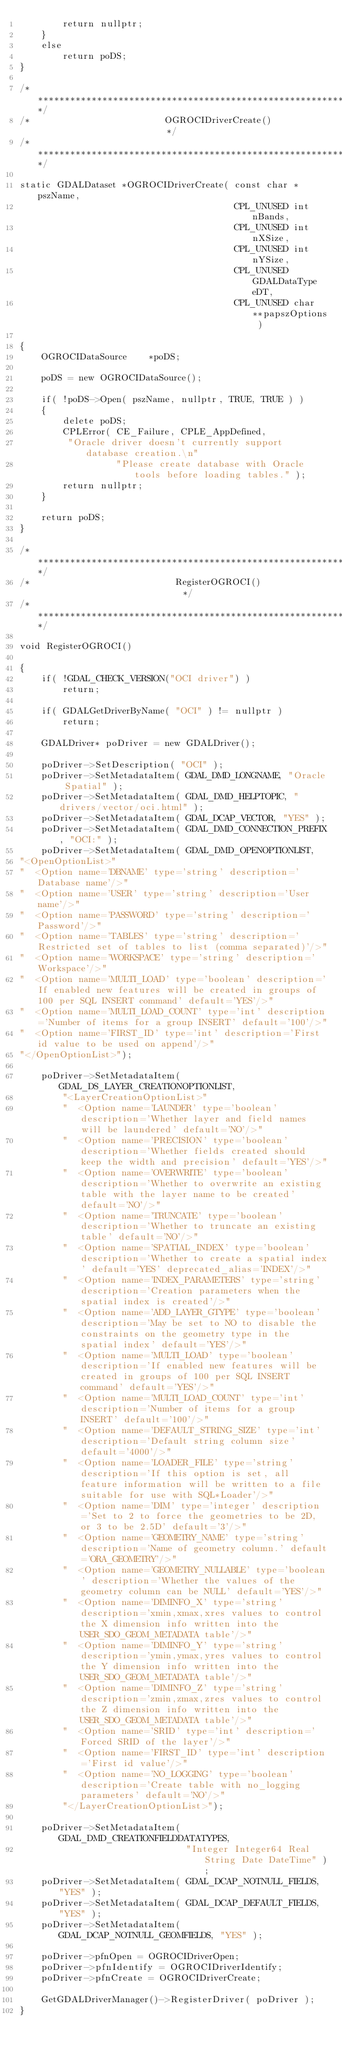<code> <loc_0><loc_0><loc_500><loc_500><_C++_>        return nullptr;
    }
    else
        return poDS;
}

/************************************************************************/
/*                         OGROCIDriverCreate()                         */
/************************************************************************/

static GDALDataset *OGROCIDriverCreate( const char * pszName,
                                        CPL_UNUSED int nBands,
                                        CPL_UNUSED int nXSize,
                                        CPL_UNUSED int nYSize,
                                        CPL_UNUSED GDALDataType eDT,
                                        CPL_UNUSED char **papszOptions )

{
    OGROCIDataSource    *poDS;

    poDS = new OGROCIDataSource();

    if( !poDS->Open( pszName, nullptr, TRUE, TRUE ) )
    {
        delete poDS;
        CPLError( CE_Failure, CPLE_AppDefined,
         "Oracle driver doesn't currently support database creation.\n"
                  "Please create database with Oracle tools before loading tables." );
        return nullptr;
    }

    return poDS;
}

/************************************************************************/
/*                           RegisterOGROCI()                            */
/************************************************************************/

void RegisterOGROCI()

{
    if( !GDAL_CHECK_VERSION("OCI driver") )
        return;

    if( GDALGetDriverByName( "OCI" ) != nullptr )
        return;

    GDALDriver* poDriver = new GDALDriver();

    poDriver->SetDescription( "OCI" );
    poDriver->SetMetadataItem( GDAL_DMD_LONGNAME, "Oracle Spatial" );
    poDriver->SetMetadataItem( GDAL_DMD_HELPTOPIC, "drivers/vector/oci.html" );
    poDriver->SetMetadataItem( GDAL_DCAP_VECTOR, "YES" );
    poDriver->SetMetadataItem( GDAL_DMD_CONNECTION_PREFIX, "OCI:" );
    poDriver->SetMetadataItem( GDAL_DMD_OPENOPTIONLIST,
"<OpenOptionList>"
"  <Option name='DBNAME' type='string' description='Database name'/>"
"  <Option name='USER' type='string' description='User name'/>"
"  <Option name='PASSWORD' type='string' description='Password'/>"
"  <Option name='TABLES' type='string' description='Restricted set of tables to list (comma separated)'/>"
"  <Option name='WORKSPACE' type='string' description='Workspace'/>"
"  <Option name='MULTI_LOAD' type='boolean' description='If enabled new features will be created in groups of 100 per SQL INSERT command' default='YES'/>"
"  <Option name='MULTI_LOAD_COUNT' type='int' description='Number of items for a group INSERT' default='100'/>"
"  <Option name='FIRST_ID' type='int' description='First id value to be used on append'/>"
"</OpenOptionList>");

    poDriver->SetMetadataItem( GDAL_DS_LAYER_CREATIONOPTIONLIST,
        "<LayerCreationOptionList>"
        "  <Option name='LAUNDER' type='boolean' description='Whether layer and field names will be laundered' default='NO'/>"
        "  <Option name='PRECISION' type='boolean' description='Whether fields created should keep the width and precision' default='YES'/>"
        "  <Option name='OVERWRITE' type='boolean' description='Whether to overwrite an existing table with the layer name to be created' default='NO'/>"
        "  <Option name='TRUNCATE' type='boolean' description='Whether to truncate an existing table' default='NO'/>"
        "  <Option name='SPATIAL_INDEX' type='boolean' description='Whether to create a spatial index' default='YES' deprecated_alias='INDEX'/>"
        "  <Option name='INDEX_PARAMETERS' type='string' description='Creation parameters when the spatial index is created'/>"
        "  <Option name='ADD_LAYER_GTYPE' type='boolean' description='May be set to NO to disable the constraints on the geometry type in the spatial index' default='YES'/>"
        "  <Option name='MULTI_LOAD' type='boolean' description='If enabled new features will be created in groups of 100 per SQL INSERT command' default='YES'/>"
        "  <Option name='MULTI_LOAD_COUNT' type='int' description='Number of items for a group INSERT' default='100'/>"
        "  <Option name='DEFAULT_STRING_SIZE' type='int' description='Default string column size' default='4000'/>"
        "  <Option name='LOADER_FILE' type='string' description='If this option is set, all feature information will be written to a file suitable for use with SQL*Loader'/>"
        "  <Option name='DIM' type='integer' description='Set to 2 to force the geometries to be 2D, or 3 to be 2.5D' default='3'/>"
        "  <Option name='GEOMETRY_NAME' type='string' description='Name of geometry column.' default='ORA_GEOMETRY'/>"
        "  <Option name='GEOMETRY_NULLABLE' type='boolean' description='Whether the values of the geometry column can be NULL' default='YES'/>"
        "  <Option name='DIMINFO_X' type='string' description='xmin,xmax,xres values to control the X dimension info written into the USER_SDO_GEOM_METADATA table'/>"
        "  <Option name='DIMINFO_Y' type='string' description='ymin,ymax,yres values to control the Y dimension info written into the USER_SDO_GEOM_METADATA table'/>"
        "  <Option name='DIMINFO_Z' type='string' description='zmin,zmax,zres values to control the Z dimension info written into the USER_SDO_GEOM_METADATA table'/>"
        "  <Option name='SRID' type='int' description='Forced SRID of the layer'/>"
        "  <Option name='FIRST_ID' type='int' description='First id value'/>"
        "  <Option name='NO_LOGGING' type='boolean' description='Create table with no_logging parameters' default='NO'/>"
        "</LayerCreationOptionList>");

    poDriver->SetMetadataItem( GDAL_DMD_CREATIONFIELDDATATYPES,
                               "Integer Integer64 Real String Date DateTime" );
    poDriver->SetMetadataItem( GDAL_DCAP_NOTNULL_FIELDS, "YES" );
    poDriver->SetMetadataItem( GDAL_DCAP_DEFAULT_FIELDS, "YES" );
    poDriver->SetMetadataItem( GDAL_DCAP_NOTNULL_GEOMFIELDS, "YES" );

    poDriver->pfnOpen = OGROCIDriverOpen;
    poDriver->pfnIdentify = OGROCIDriverIdentify;
    poDriver->pfnCreate = OGROCIDriverCreate;

    GetGDALDriverManager()->RegisterDriver( poDriver );
}
</code> 